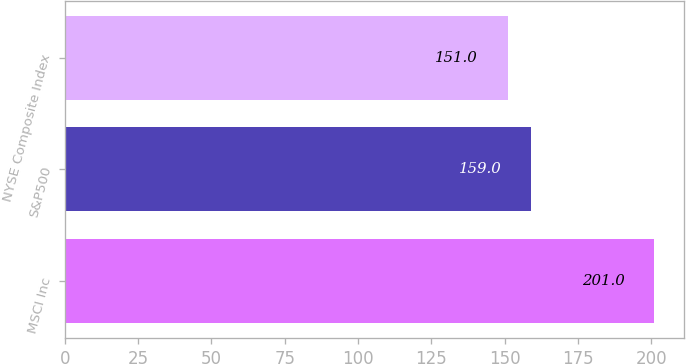<chart> <loc_0><loc_0><loc_500><loc_500><bar_chart><fcel>MSCI Inc<fcel>S&P500<fcel>NYSE Composite Index<nl><fcel>201<fcel>159<fcel>151<nl></chart> 